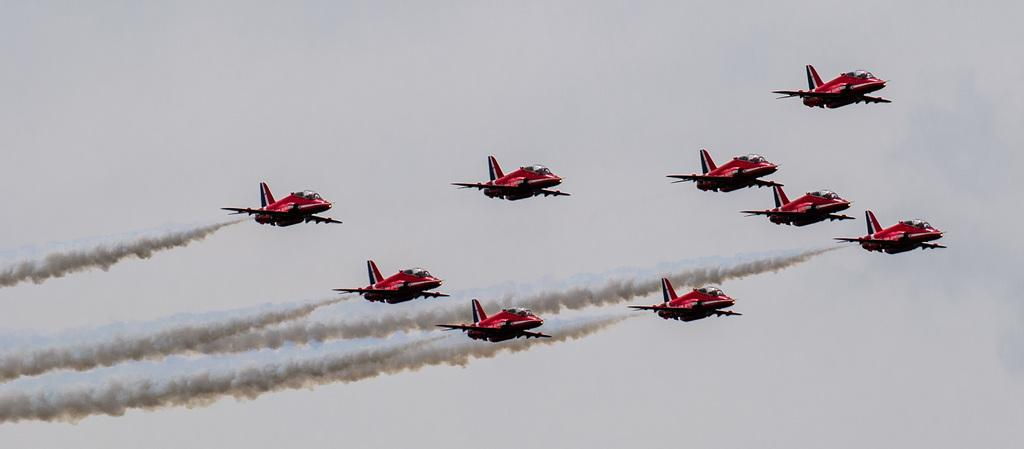What is the main subject of the image? The main subject of the image is airplanes. What are the airplanes doing in the image? The airplanes are flying in the air. What can be seen behind the airplanes? There is smoke behind the airplanes. What is visible in the background of the image? The sky is visible in the background of the image. What type of blade can be seen in the image? There is no blade present in the image; it features airplanes flying in the air with smoke behind them. Can you tell me how many eyes are visible in the image? There are no eyes visible in the image, as it does not contain any living beings with eyes. 